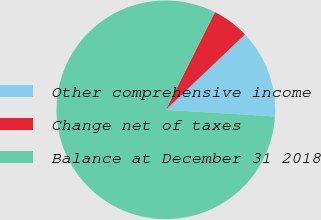Convert chart. <chart><loc_0><loc_0><loc_500><loc_500><pie_chart><fcel>Other comprehensive income<fcel>Change net of taxes<fcel>Balance at December 31 2018<nl><fcel>13.07%<fcel>5.48%<fcel>81.45%<nl></chart> 